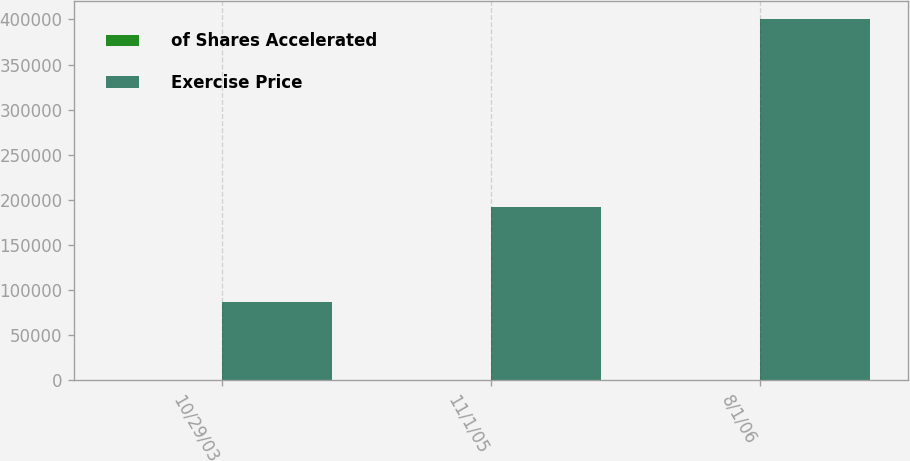Convert chart to OTSL. <chart><loc_0><loc_0><loc_500><loc_500><stacked_bar_chart><ecel><fcel>10/29/03<fcel>11/1/05<fcel>8/1/06<nl><fcel>of Shares Accelerated<fcel>15.87<fcel>23.46<fcel>17.94<nl><fcel>Exercise Price<fcel>86340<fcel>192650<fcel>400813<nl></chart> 